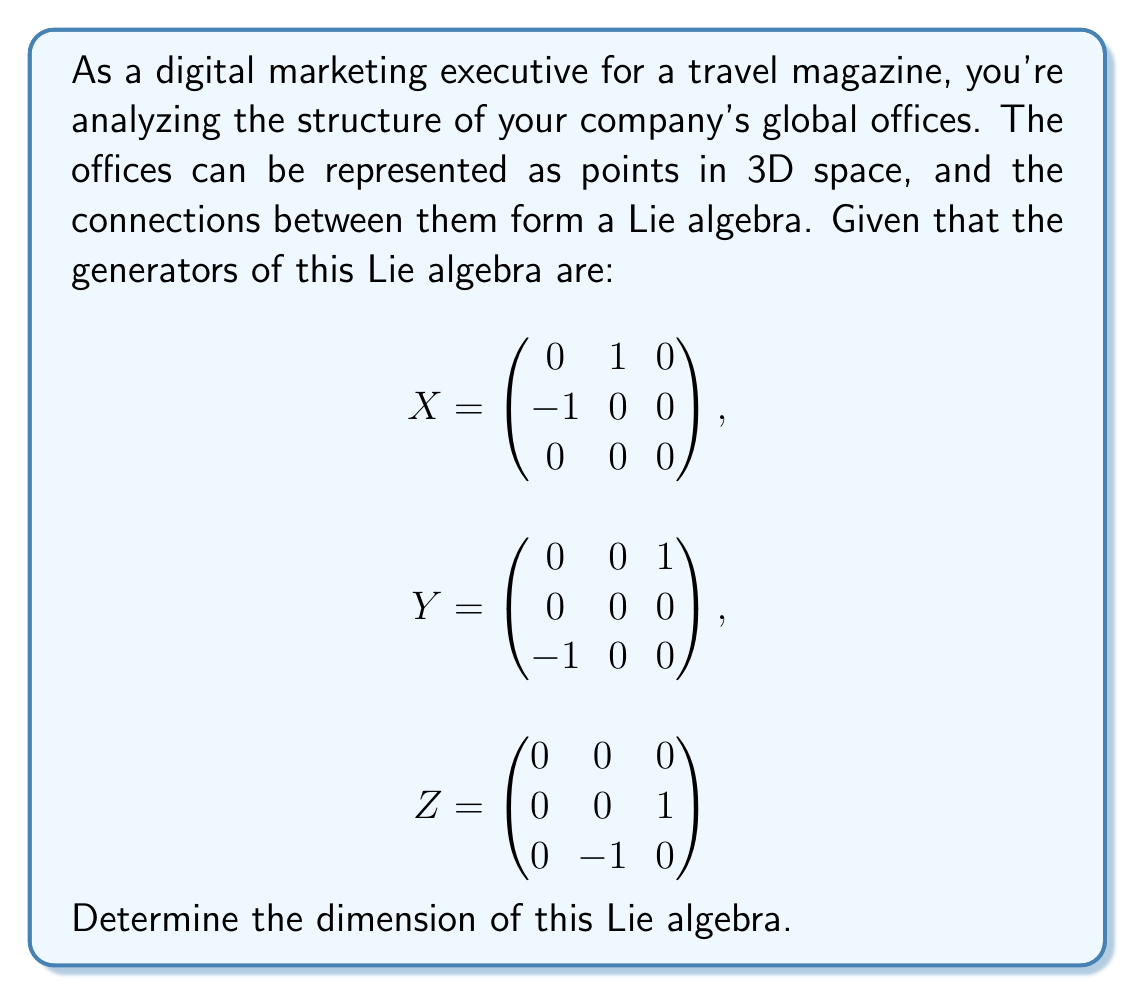Solve this math problem. To determine the dimension of a Lie algebra, we need to find the number of linearly independent generators. In this case, we're given three generators: $X$, $Y$, and $Z$.

Step 1: Check linear independence
To check if these generators are linearly independent, we need to ensure that no linear combination of them equals the zero matrix, except when all coefficients are zero.

Let's assume there exists a linear combination that equals zero:
$$aX + bY + cZ = 0$$

where $a$, $b$, and $c$ are scalars.

Step 2: Expand the equation
$$a\begin{pmatrix} 0 & 1 & 0 \\ -1 & 0 & 0 \\ 0 & 0 & 0 \end{pmatrix} +
b\begin{pmatrix} 0 & 0 & 1 \\ 0 & 0 & 0 \\ -1 & 0 & 0 \end{pmatrix} +
c\begin{pmatrix} 0 & 0 & 0 \\ 0 & 0 & 1 \\ 0 & -1 & 0 \end{pmatrix} =
\begin{pmatrix} 0 & 0 & 0 \\ 0 & 0 & 0 \\ 0 & 0 & 0 \end{pmatrix}$$

Step 3: Equate corresponding elements
This gives us the following system of equations:
$$\begin{aligned}
a &= 0 \\
b &= 0 \\
c &= 0
\end{aligned}$$

Step 4: Analyze the result
Since the only solution to this system is $a = b = c = 0$, we can conclude that $X$, $Y$, and $Z$ are linearly independent.

Step 5: Determine the dimension
The dimension of a Lie algebra is equal to the number of linearly independent generators. In this case, we have three linearly independent generators.

Therefore, the dimension of the Lie algebra is 3.
Answer: The dimension of the Lie algebra is 3. 